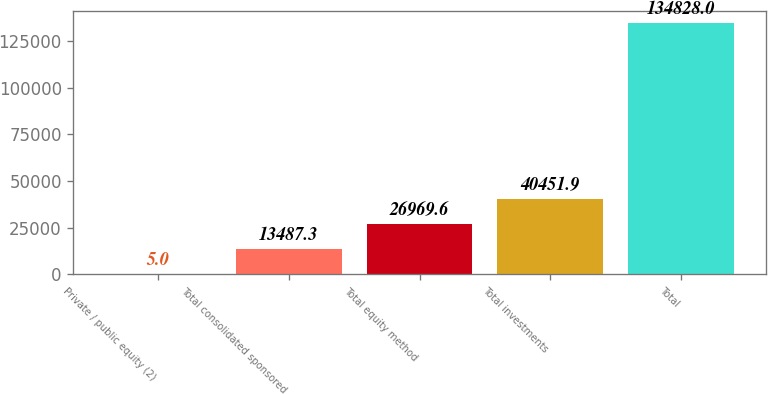Convert chart. <chart><loc_0><loc_0><loc_500><loc_500><bar_chart><fcel>Private / public equity (2)<fcel>Total consolidated sponsored<fcel>Total equity method<fcel>Total investments<fcel>Total<nl><fcel>5<fcel>13487.3<fcel>26969.6<fcel>40451.9<fcel>134828<nl></chart> 